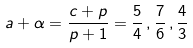Convert formula to latex. <formula><loc_0><loc_0><loc_500><loc_500>a + \alpha = \frac { c + p } { p + 1 } = \frac { 5 } { 4 } \, , \frac { 7 } { 6 } \, , \frac { 4 } { 3 }</formula> 